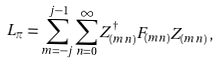<formula> <loc_0><loc_0><loc_500><loc_500>L _ { \pi } = \sum ^ { j - 1 } _ { m = - j } \sum ^ { \infty } _ { n = 0 } Z _ { ( m n ) } ^ { \dagger } F _ { ( m n ) } Z _ { ( m n ) } \, ,</formula> 